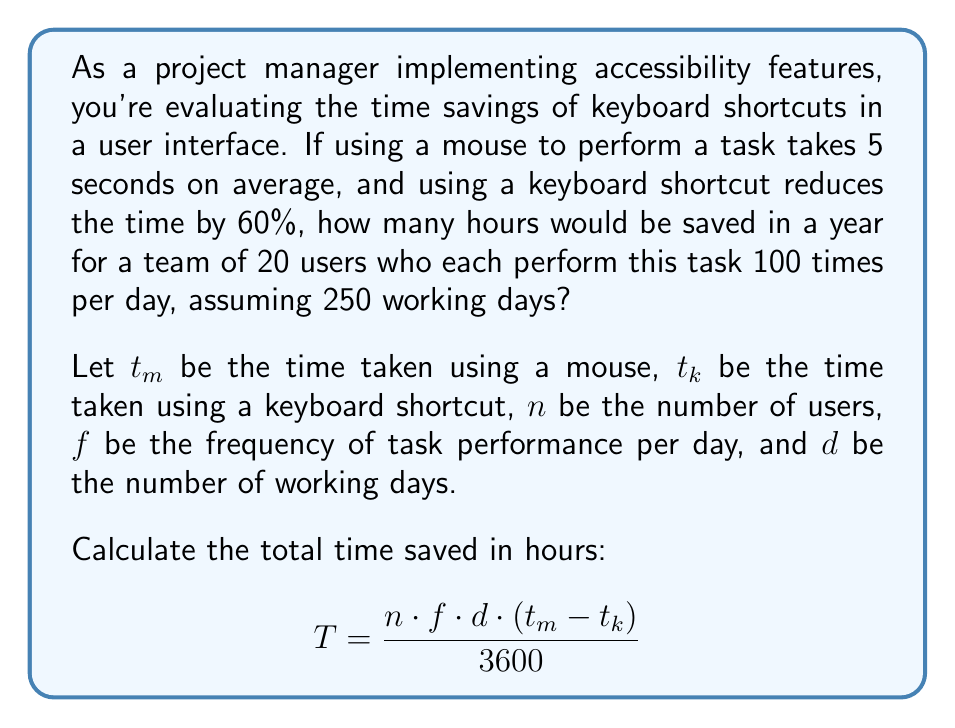Solve this math problem. To solve this problem, let's break it down step by step:

1. Calculate the time taken using a keyboard shortcut:
   $t_k = t_m - (60\% \cdot t_m) = 5 - (0.6 \cdot 5) = 5 - 3 = 2$ seconds

2. Calculate the time saved per task:
   Time saved = $t_m - t_k = 5 - 2 = 3$ seconds

3. Now, let's plug in the values to our equation:
   $n = 20$ users
   $f = 100$ times per day
   $d = 250$ working days
   Time saved per task = 3 seconds

   $$T = \frac{20 \cdot 100 \cdot 250 \cdot 3}{3600}$$

4. Simplify:
   $$T = \frac{1,500,000}{3600} = 416.67$$

The result is in hours, so we don't need to convert further.
Answer: 416.67 hours 